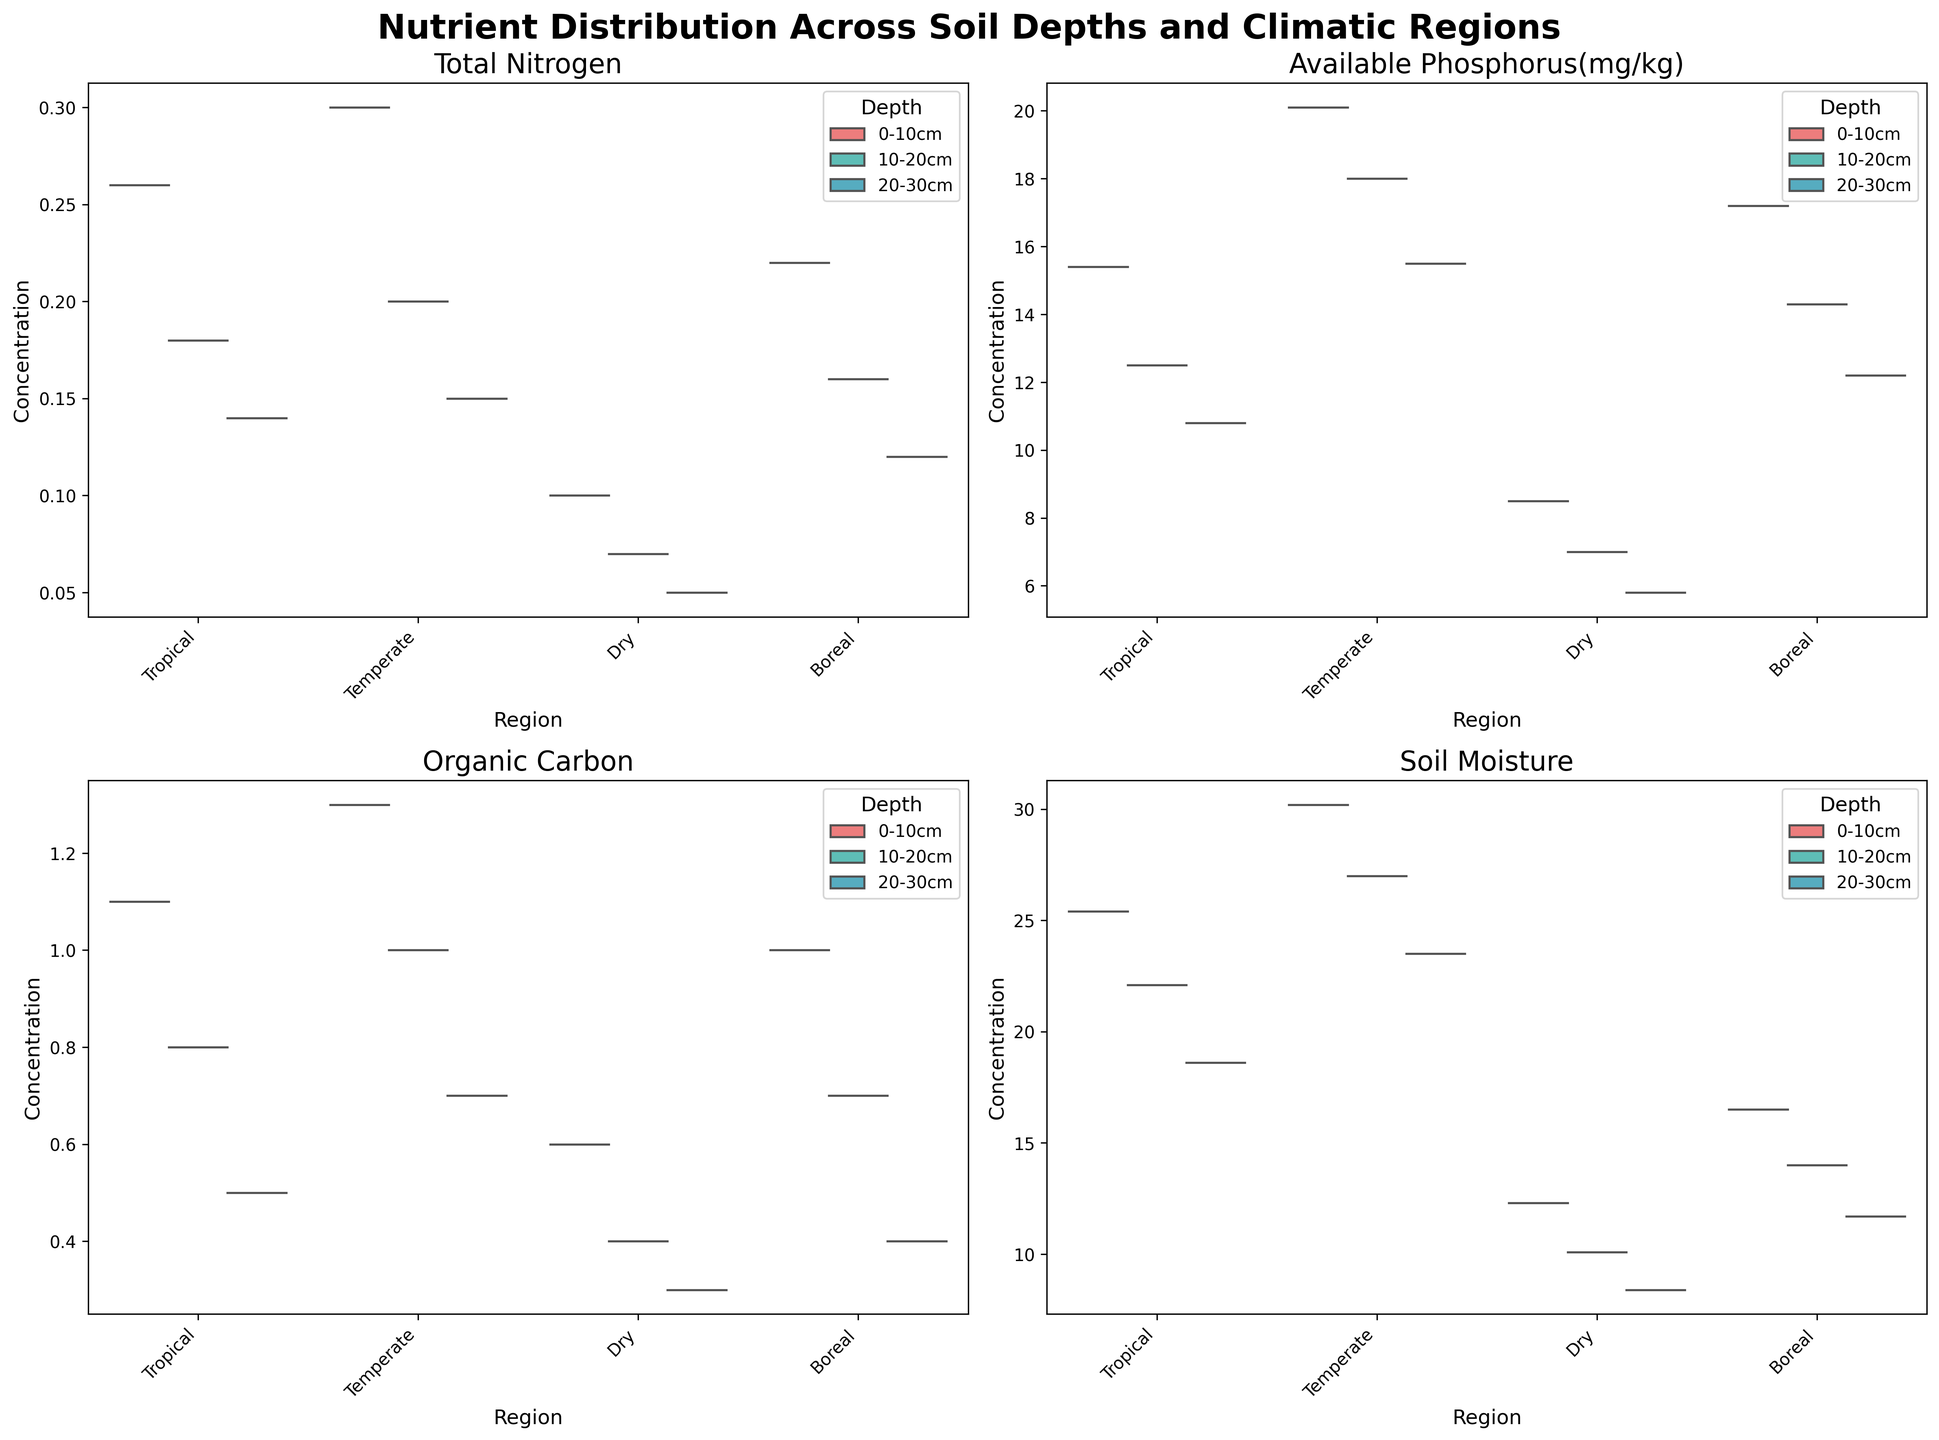What is the overall title of the figure? The overall title is indicated at the very top of the figure and should summarize the content of the plot. In this case, it is descriptive of the data plotted.
Answer: Nutrient Distribution Across Soil Depths and Climatic Regions Which region has the highest median Total Nitrogen (%) at 0-10cm depth? To find this, look at the violin plots for the 'Total_Nitrogen(%)' section, specifically focusing on the 0-10cm depth median values across the different regions. Identify which region's median line (the white dot inside the box plot) is the highest.
Answer: Temperate What is the overall trend of Soil Moisture (%) with increasing depth for the Tropical region? Observe the Soil Moisture (%) section for the Tropical region and notice how the median values for each depth change. Check if the median values for 0-10cm, 10-20cm, and 20-30cm show an increasing or decreasing pattern.
Answer: Decreasing Between the Temperate and Dry regions, which shows a higher variance in Available Phosphorus (mg/kg) at 0-10cm depth? Examine the range and spread of the violin plots for Available Phosphorus (mg/kg) at the 0-10cm depth for both Temperate and Dry regions. The region with wider or more spread-out violin shape has higher variance.
Answer: Temperate How does the median Organic Carbon (%) at 20-30cm depth in the Boreal region compare to that in the Tropical region? Look at the median lines (inside the box plots) for Organic Carbon (%) at 20-30cm depth in both Boreal and Tropical regions. Compare their positions to determine which is higher or if they are equal.
Answer: Boreal is higher Which region demonstrates the least drop in Organic Carbon (%) between 0-10cm and 10-20cm depths? For each region, look at the Organic Carbon (%) values at 0-10cm and 10-20cm depths, and calculate the difference. The region with the smallest difference has the least drop.
Answer: Temperate In the Dry region, what is the relationship between depth and Available Phosphorus (mg/kg)? Inspect the Available Phosphorus (mg/kg) violin plots for the Dry region, focusing on the pattern across the depths (0-10cm, 10-20cm, 20-30cm). Identify whether the values consistently rise, fall, or stay the same.
Answer: Decreasing Do the Boreal and Tropical regions have similar median Soil Moisture (%) at 20-30cm depth? Compare the median lines for Soil Moisture (%) at 20-30cm depth in both Boreal and Tropical regions. Determine if they fall at approximately the same value or differ significantly.
Answer: No, Boreal is lower Which nutrient shows the most distinct difference in median values across all regions at 0-10cm depth? For each nutrient at 0-10cm depth, compare the median values across all regions. Identify the nutrient where the median values differ the most between regions.
Answer: Available_Phosphorus(mg/kg) Which depth category in the Temperate region has the highest median Organic Carbon (%)? Look at the violin plots for Organic Carbon (%) in the Temperate region, identifying the median lines for each depth category (0-10cm, 10-20cm, 20-30cm) and noting which is highest.
Answer: 0-10cm 